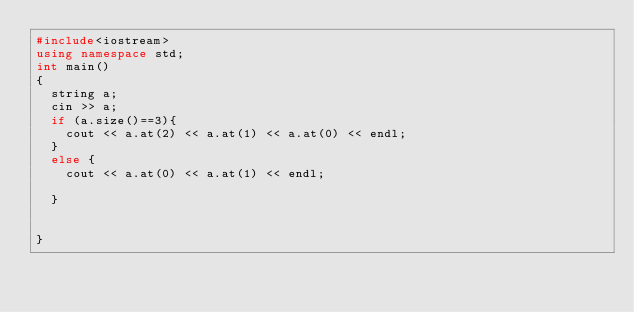Convert code to text. <code><loc_0><loc_0><loc_500><loc_500><_C++_>#include<iostream>
using namespace std;
int main()
{
  string a;
  cin >> a;
  if (a.size()==3){
    cout << a.at(2) << a.at(1) << a.at(0) << endl;
  }
  else {
    cout << a.at(0) << a.at(1) << endl;
      
  }
    
  
}</code> 